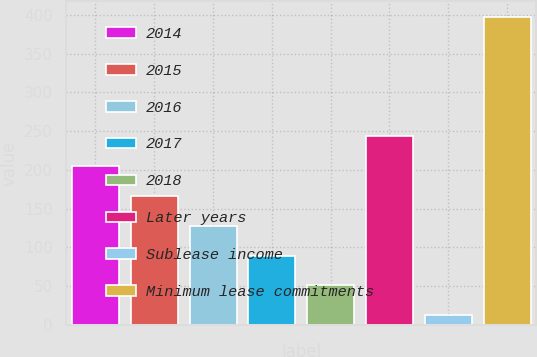Convert chart. <chart><loc_0><loc_0><loc_500><loc_500><bar_chart><fcel>2014<fcel>2015<fcel>2016<fcel>2017<fcel>2018<fcel>Later years<fcel>Sublease income<fcel>Minimum lease commitments<nl><fcel>205<fcel>166.4<fcel>127.8<fcel>89.2<fcel>50.6<fcel>243.6<fcel>12<fcel>398<nl></chart> 